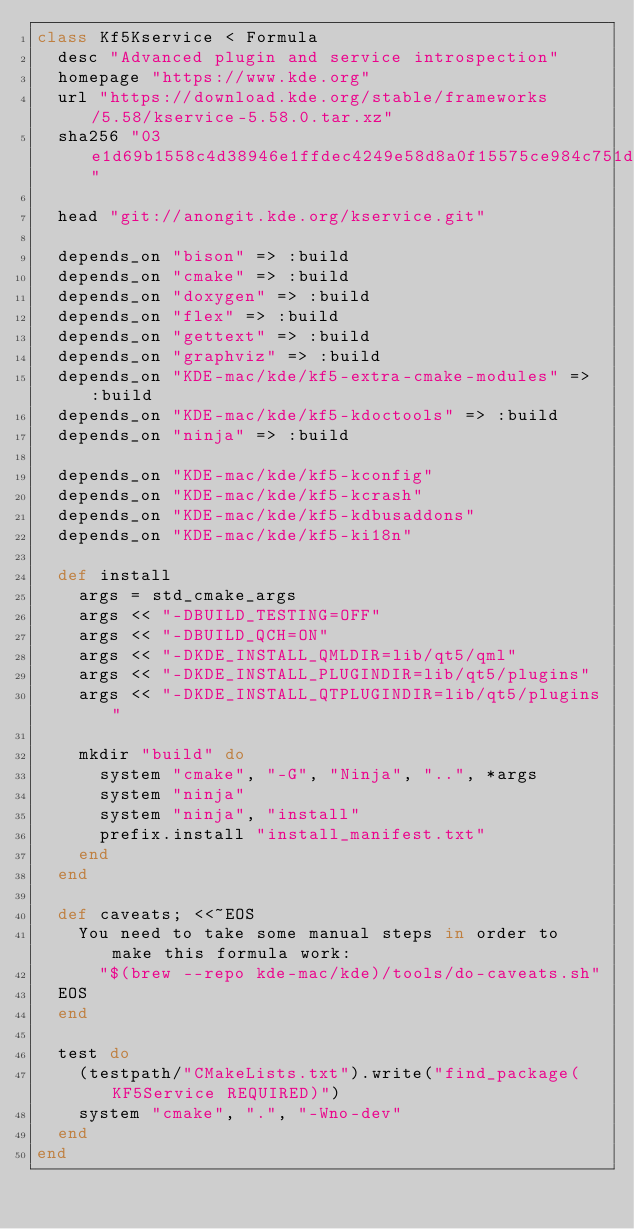Convert code to text. <code><loc_0><loc_0><loc_500><loc_500><_Ruby_>class Kf5Kservice < Formula
  desc "Advanced plugin and service introspection"
  homepage "https://www.kde.org"
  url "https://download.kde.org/stable/frameworks/5.58/kservice-5.58.0.tar.xz"
  sha256 "03e1d69b1558c4d38946e1ffdec4249e58d8a0f15575ce984c751d93b3ff1395"

  head "git://anongit.kde.org/kservice.git"

  depends_on "bison" => :build
  depends_on "cmake" => :build
  depends_on "doxygen" => :build
  depends_on "flex" => :build
  depends_on "gettext" => :build
  depends_on "graphviz" => :build
  depends_on "KDE-mac/kde/kf5-extra-cmake-modules" => :build
  depends_on "KDE-mac/kde/kf5-kdoctools" => :build
  depends_on "ninja" => :build

  depends_on "KDE-mac/kde/kf5-kconfig"
  depends_on "KDE-mac/kde/kf5-kcrash"
  depends_on "KDE-mac/kde/kf5-kdbusaddons"
  depends_on "KDE-mac/kde/kf5-ki18n"

  def install
    args = std_cmake_args
    args << "-DBUILD_TESTING=OFF"
    args << "-DBUILD_QCH=ON"
    args << "-DKDE_INSTALL_QMLDIR=lib/qt5/qml"
    args << "-DKDE_INSTALL_PLUGINDIR=lib/qt5/plugins"
    args << "-DKDE_INSTALL_QTPLUGINDIR=lib/qt5/plugins"

    mkdir "build" do
      system "cmake", "-G", "Ninja", "..", *args
      system "ninja"
      system "ninja", "install"
      prefix.install "install_manifest.txt"
    end
  end

  def caveats; <<~EOS
    You need to take some manual steps in order to make this formula work:
      "$(brew --repo kde-mac/kde)/tools/do-caveats.sh"
  EOS
  end

  test do
    (testpath/"CMakeLists.txt").write("find_package(KF5Service REQUIRED)")
    system "cmake", ".", "-Wno-dev"
  end
end
</code> 